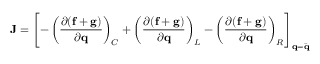<formula> <loc_0><loc_0><loc_500><loc_500>J = \left [ - \left ( \frac { \partial ( f + g ) } { \partial q } \right ) _ { C } + \left ( \frac { \partial ( f + g ) } { \partial q } \right ) _ { L } - \left ( \frac { \partial ( f + g ) } { \partial q } \right ) _ { R } \right ] _ { q = \ B a r { q } }</formula> 